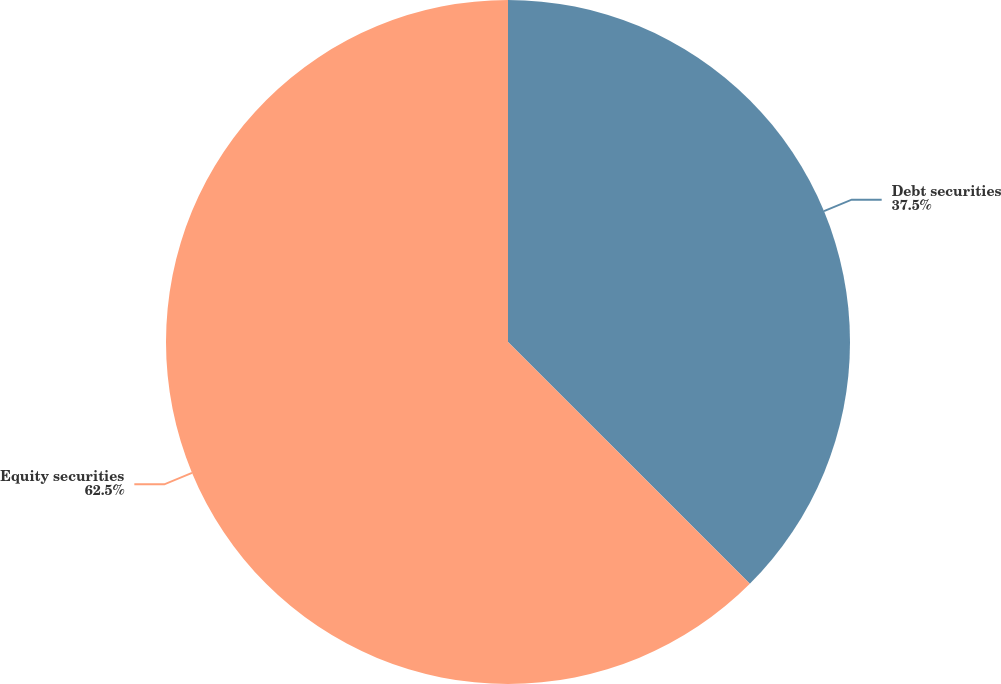Convert chart to OTSL. <chart><loc_0><loc_0><loc_500><loc_500><pie_chart><fcel>Debt securities<fcel>Equity securities<nl><fcel>37.5%<fcel>62.5%<nl></chart> 